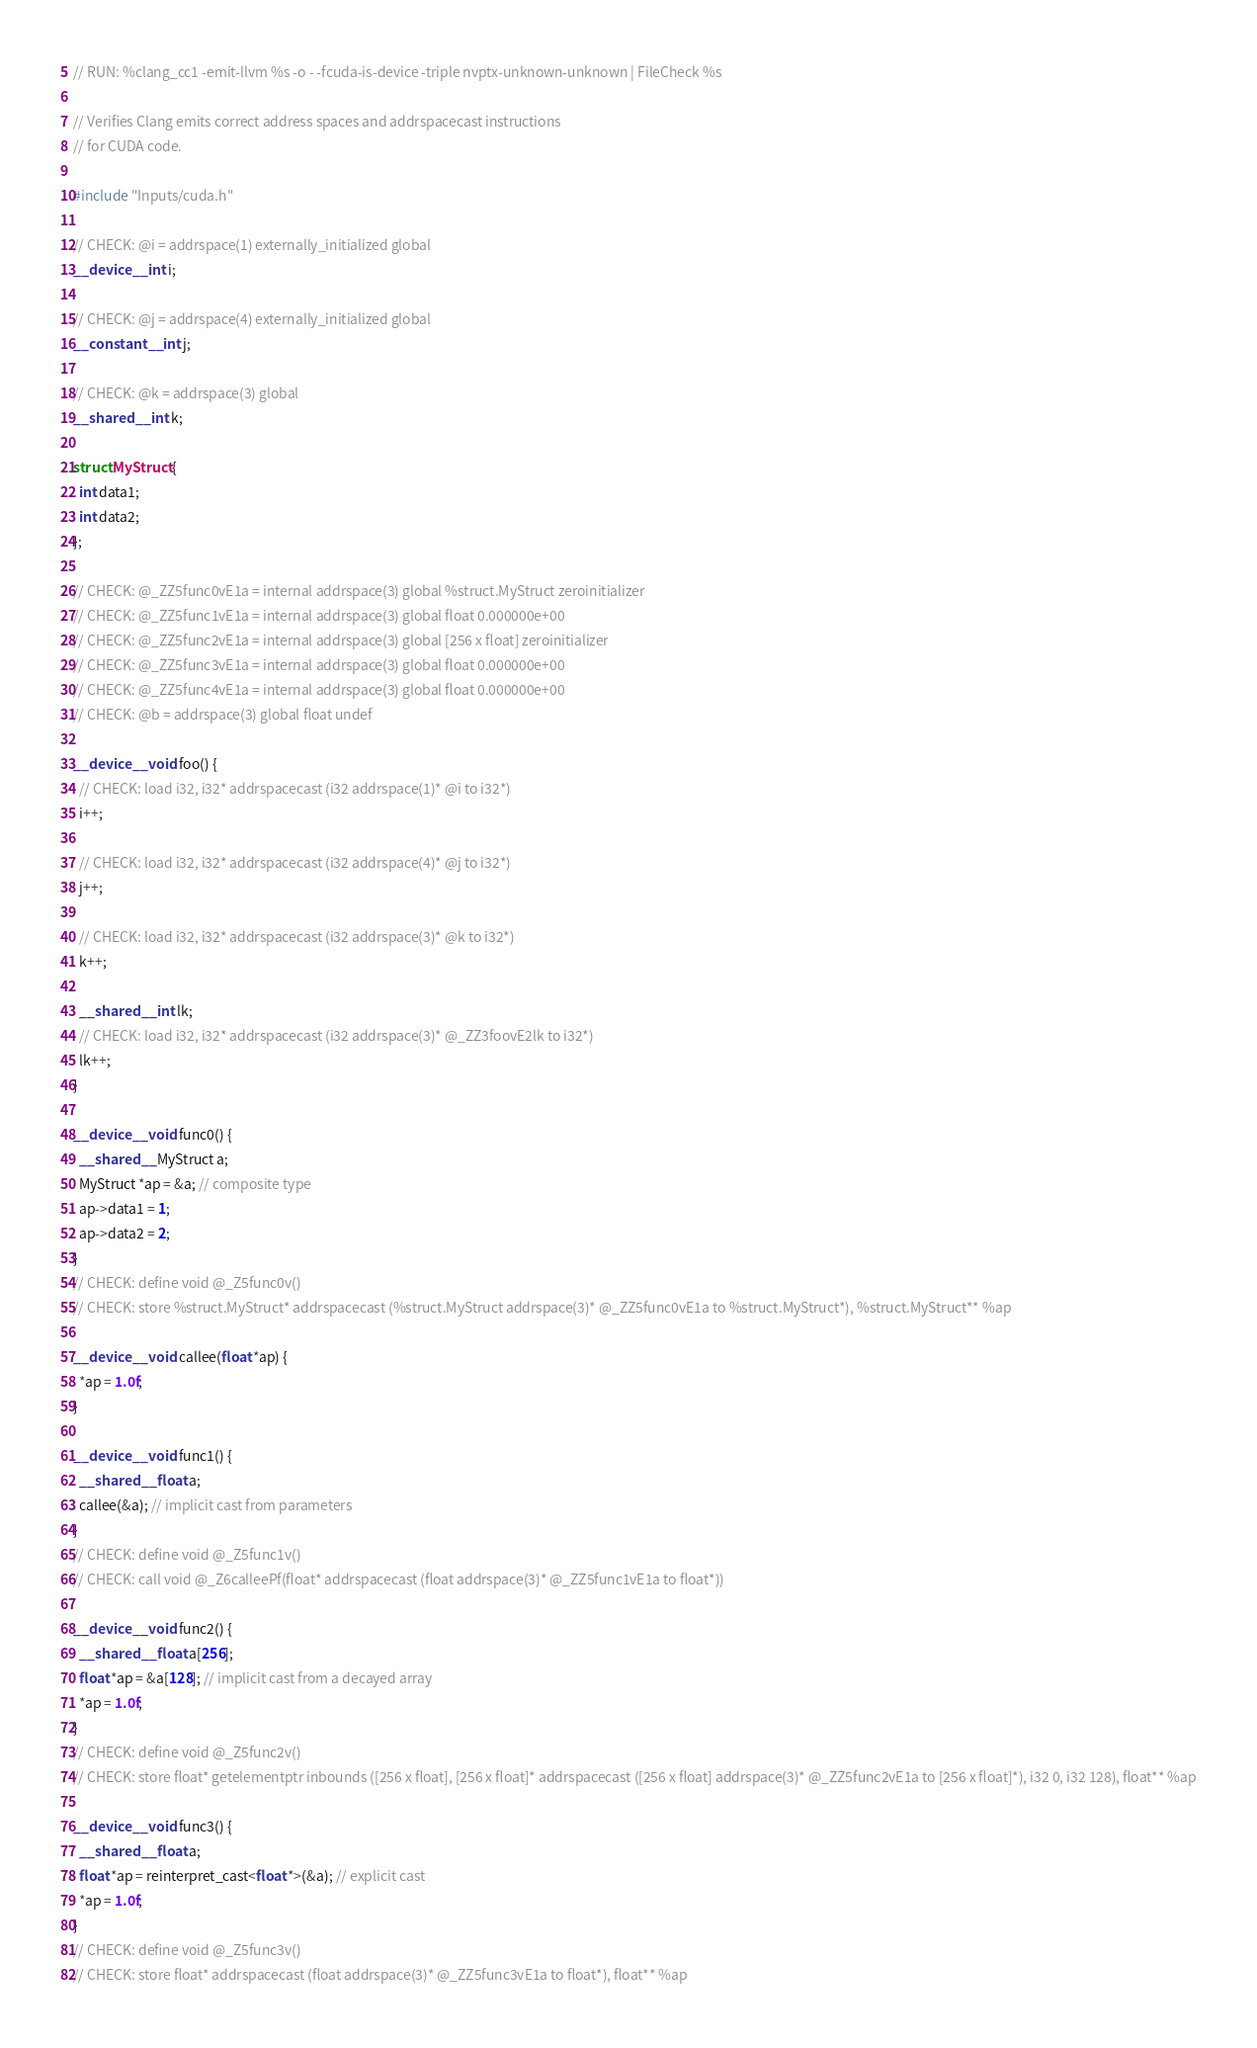Convert code to text. <code><loc_0><loc_0><loc_500><loc_500><_Cuda_>// RUN: %clang_cc1 -emit-llvm %s -o - -fcuda-is-device -triple nvptx-unknown-unknown | FileCheck %s

// Verifies Clang emits correct address spaces and addrspacecast instructions
// for CUDA code.

#include "Inputs/cuda.h"

// CHECK: @i = addrspace(1) externally_initialized global
__device__ int i;

// CHECK: @j = addrspace(4) externally_initialized global
__constant__ int j;

// CHECK: @k = addrspace(3) global
__shared__ int k;

struct MyStruct {
  int data1;
  int data2;
};

// CHECK: @_ZZ5func0vE1a = internal addrspace(3) global %struct.MyStruct zeroinitializer
// CHECK: @_ZZ5func1vE1a = internal addrspace(3) global float 0.000000e+00
// CHECK: @_ZZ5func2vE1a = internal addrspace(3) global [256 x float] zeroinitializer
// CHECK: @_ZZ5func3vE1a = internal addrspace(3) global float 0.000000e+00
// CHECK: @_ZZ5func4vE1a = internal addrspace(3) global float 0.000000e+00
// CHECK: @b = addrspace(3) global float undef

__device__ void foo() {
  // CHECK: load i32, i32* addrspacecast (i32 addrspace(1)* @i to i32*)
  i++;

  // CHECK: load i32, i32* addrspacecast (i32 addrspace(4)* @j to i32*)
  j++;

  // CHECK: load i32, i32* addrspacecast (i32 addrspace(3)* @k to i32*)
  k++;

  __shared__ int lk;
  // CHECK: load i32, i32* addrspacecast (i32 addrspace(3)* @_ZZ3foovE2lk to i32*)
  lk++;
}

__device__ void func0() {
  __shared__ MyStruct a;
  MyStruct *ap = &a; // composite type
  ap->data1 = 1;
  ap->data2 = 2;
}
// CHECK: define void @_Z5func0v()
// CHECK: store %struct.MyStruct* addrspacecast (%struct.MyStruct addrspace(3)* @_ZZ5func0vE1a to %struct.MyStruct*), %struct.MyStruct** %ap

__device__ void callee(float *ap) {
  *ap = 1.0f;
}

__device__ void func1() {
  __shared__ float a;
  callee(&a); // implicit cast from parameters
}
// CHECK: define void @_Z5func1v()
// CHECK: call void @_Z6calleePf(float* addrspacecast (float addrspace(3)* @_ZZ5func1vE1a to float*))

__device__ void func2() {
  __shared__ float a[256];
  float *ap = &a[128]; // implicit cast from a decayed array
  *ap = 1.0f;
}
// CHECK: define void @_Z5func2v()
// CHECK: store float* getelementptr inbounds ([256 x float], [256 x float]* addrspacecast ([256 x float] addrspace(3)* @_ZZ5func2vE1a to [256 x float]*), i32 0, i32 128), float** %ap

__device__ void func3() {
  __shared__ float a;
  float *ap = reinterpret_cast<float *>(&a); // explicit cast
  *ap = 1.0f;
}
// CHECK: define void @_Z5func3v()
// CHECK: store float* addrspacecast (float addrspace(3)* @_ZZ5func3vE1a to float*), float** %ap
</code> 